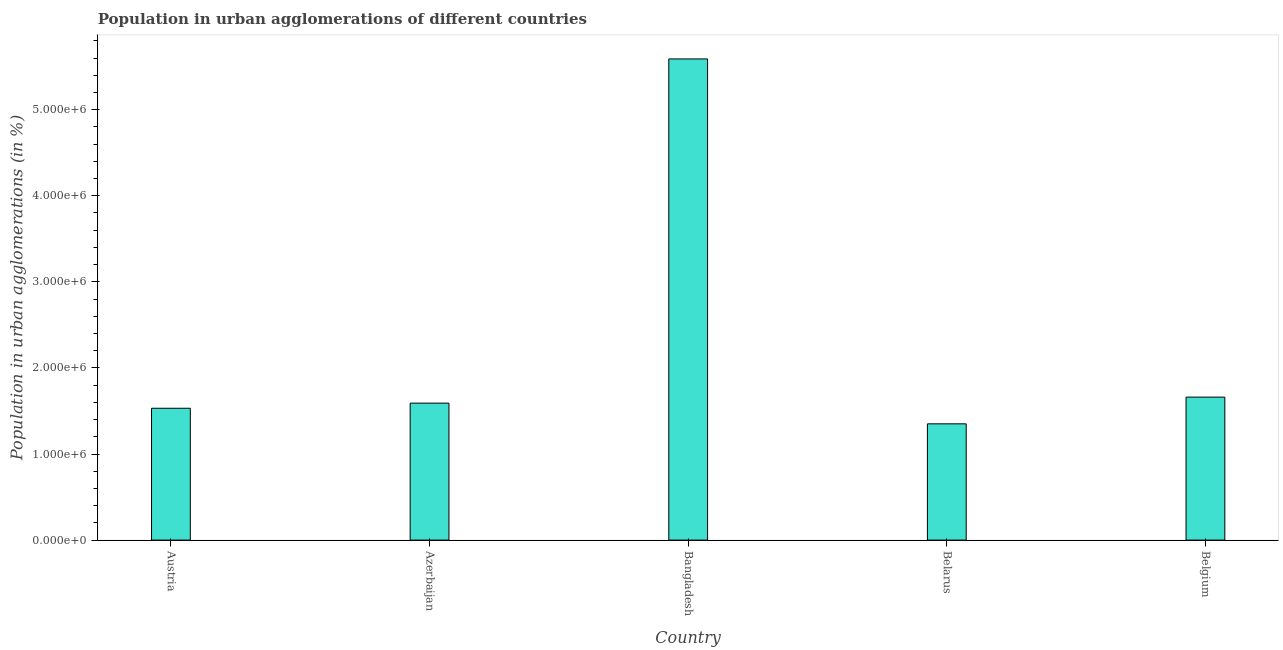Does the graph contain any zero values?
Offer a terse response. No. Does the graph contain grids?
Your answer should be compact. No. What is the title of the graph?
Ensure brevity in your answer.  Population in urban agglomerations of different countries. What is the label or title of the X-axis?
Your answer should be very brief. Country. What is the label or title of the Y-axis?
Give a very brief answer. Population in urban agglomerations (in %). What is the population in urban agglomerations in Austria?
Offer a terse response. 1.53e+06. Across all countries, what is the maximum population in urban agglomerations?
Your response must be concise. 5.59e+06. Across all countries, what is the minimum population in urban agglomerations?
Give a very brief answer. 1.35e+06. In which country was the population in urban agglomerations minimum?
Your answer should be very brief. Belarus. What is the sum of the population in urban agglomerations?
Provide a succinct answer. 1.17e+07. What is the difference between the population in urban agglomerations in Azerbaijan and Bangladesh?
Your answer should be very brief. -4.00e+06. What is the average population in urban agglomerations per country?
Offer a terse response. 2.34e+06. What is the median population in urban agglomerations?
Give a very brief answer. 1.59e+06. In how many countries, is the population in urban agglomerations greater than 3200000 %?
Offer a very short reply. 1. What is the ratio of the population in urban agglomerations in Austria to that in Belgium?
Offer a terse response. 0.92. Is the population in urban agglomerations in Belarus less than that in Belgium?
Give a very brief answer. Yes. Is the difference between the population in urban agglomerations in Bangladesh and Belgium greater than the difference between any two countries?
Your answer should be very brief. No. What is the difference between the highest and the second highest population in urban agglomerations?
Offer a very short reply. 3.93e+06. Is the sum of the population in urban agglomerations in Bangladesh and Belarus greater than the maximum population in urban agglomerations across all countries?
Keep it short and to the point. Yes. What is the difference between the highest and the lowest population in urban agglomerations?
Your answer should be compact. 4.24e+06. In how many countries, is the population in urban agglomerations greater than the average population in urban agglomerations taken over all countries?
Your response must be concise. 1. How many bars are there?
Provide a short and direct response. 5. Are all the bars in the graph horizontal?
Offer a terse response. No. How many countries are there in the graph?
Provide a short and direct response. 5. Are the values on the major ticks of Y-axis written in scientific E-notation?
Give a very brief answer. Yes. What is the Population in urban agglomerations (in %) of Austria?
Your answer should be very brief. 1.53e+06. What is the Population in urban agglomerations (in %) of Azerbaijan?
Keep it short and to the point. 1.59e+06. What is the Population in urban agglomerations (in %) in Bangladesh?
Give a very brief answer. 5.59e+06. What is the Population in urban agglomerations (in %) of Belarus?
Make the answer very short. 1.35e+06. What is the Population in urban agglomerations (in %) in Belgium?
Your answer should be compact. 1.66e+06. What is the difference between the Population in urban agglomerations (in %) in Austria and Azerbaijan?
Your answer should be compact. -5.97e+04. What is the difference between the Population in urban agglomerations (in %) in Austria and Bangladesh?
Your response must be concise. -4.06e+06. What is the difference between the Population in urban agglomerations (in %) in Austria and Belarus?
Provide a short and direct response. 1.81e+05. What is the difference between the Population in urban agglomerations (in %) in Austria and Belgium?
Your response must be concise. -1.29e+05. What is the difference between the Population in urban agglomerations (in %) in Azerbaijan and Bangladesh?
Give a very brief answer. -4.00e+06. What is the difference between the Population in urban agglomerations (in %) in Azerbaijan and Belarus?
Offer a terse response. 2.41e+05. What is the difference between the Population in urban agglomerations (in %) in Azerbaijan and Belgium?
Make the answer very short. -6.98e+04. What is the difference between the Population in urban agglomerations (in %) in Bangladesh and Belarus?
Offer a terse response. 4.24e+06. What is the difference between the Population in urban agglomerations (in %) in Bangladesh and Belgium?
Keep it short and to the point. 3.93e+06. What is the difference between the Population in urban agglomerations (in %) in Belarus and Belgium?
Give a very brief answer. -3.10e+05. What is the ratio of the Population in urban agglomerations (in %) in Austria to that in Azerbaijan?
Make the answer very short. 0.96. What is the ratio of the Population in urban agglomerations (in %) in Austria to that in Bangladesh?
Make the answer very short. 0.27. What is the ratio of the Population in urban agglomerations (in %) in Austria to that in Belarus?
Keep it short and to the point. 1.13. What is the ratio of the Population in urban agglomerations (in %) in Austria to that in Belgium?
Ensure brevity in your answer.  0.92. What is the ratio of the Population in urban agglomerations (in %) in Azerbaijan to that in Bangladesh?
Give a very brief answer. 0.28. What is the ratio of the Population in urban agglomerations (in %) in Azerbaijan to that in Belarus?
Offer a terse response. 1.18. What is the ratio of the Population in urban agglomerations (in %) in Azerbaijan to that in Belgium?
Make the answer very short. 0.96. What is the ratio of the Population in urban agglomerations (in %) in Bangladesh to that in Belarus?
Offer a terse response. 4.14. What is the ratio of the Population in urban agglomerations (in %) in Bangladesh to that in Belgium?
Provide a succinct answer. 3.37. What is the ratio of the Population in urban agglomerations (in %) in Belarus to that in Belgium?
Offer a terse response. 0.81. 